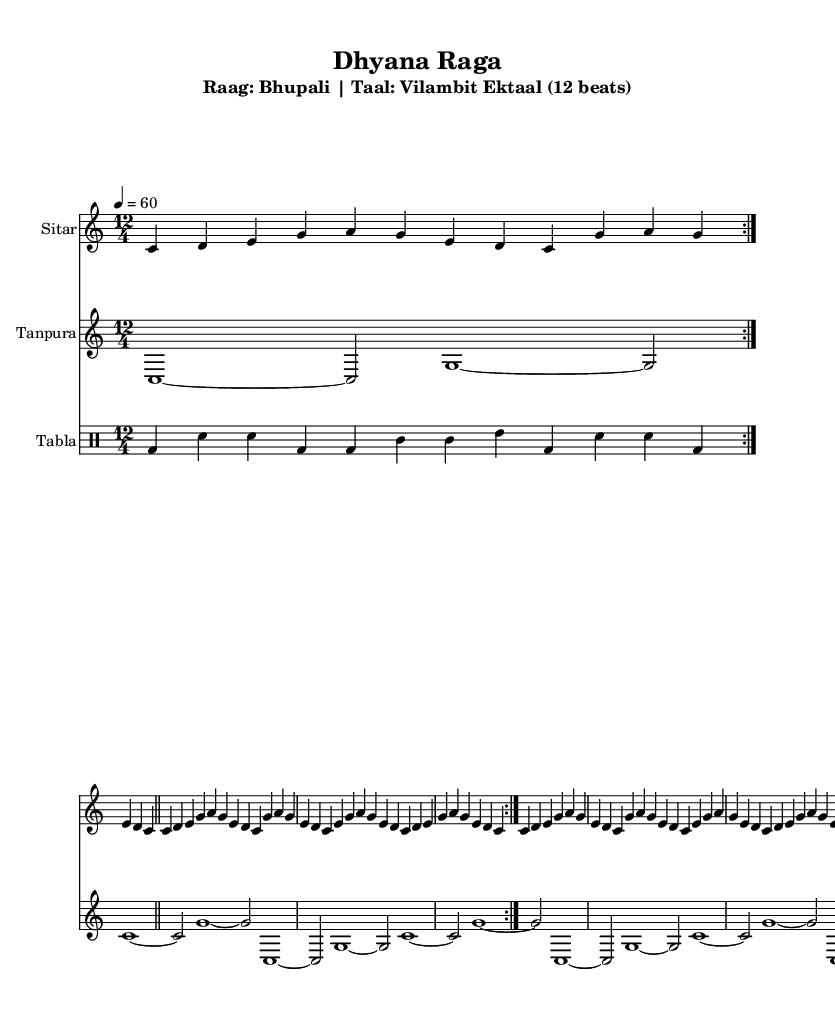What is the key signature of this music? The key signature is C major, which has no sharps or flats indicated on the staff at the beginning of the score.
Answer: C major What is the time signature used in this piece? The time signature shown at the beginning of the score indicates 12/4, meaning there are twelve beats in a measure with each beat being a quarter note.
Answer: 12/4 What is the tempo marking for this composition? The tempo marking specifies a speed of 60 beats per minute with a quarter note as the reference beat, indicated at the beginning of the score.
Answer: 60 How many measures are in the Jor section? The Jor section contains two repeated measures as indicated by the repeat symbols. As there are two cycles, this counts as a total of four measures.
Answer: 4 What type of ensemble is this score for? The score displays parts for three instruments: a sitar, a tanpura, and tabla, typical of Indian classical music ensembles.
Answer: Ensemble What is the name of this Raga? The title of the piece includes "Raag: Bhupali," identifying the specific Indian classical raga featured in this composition.
Answer: Bhupali What is the Taal used in this piece? The score specifies "Taal: Vilambit Ektaal (12 beats)" which indicates the rhythmic cycle being used for this performance.
Answer: Vilambit Ektaal 